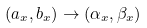<formula> <loc_0><loc_0><loc_500><loc_500>( a _ { x } , b _ { x } ) \to ( \alpha _ { x } , \beta _ { x } )</formula> 